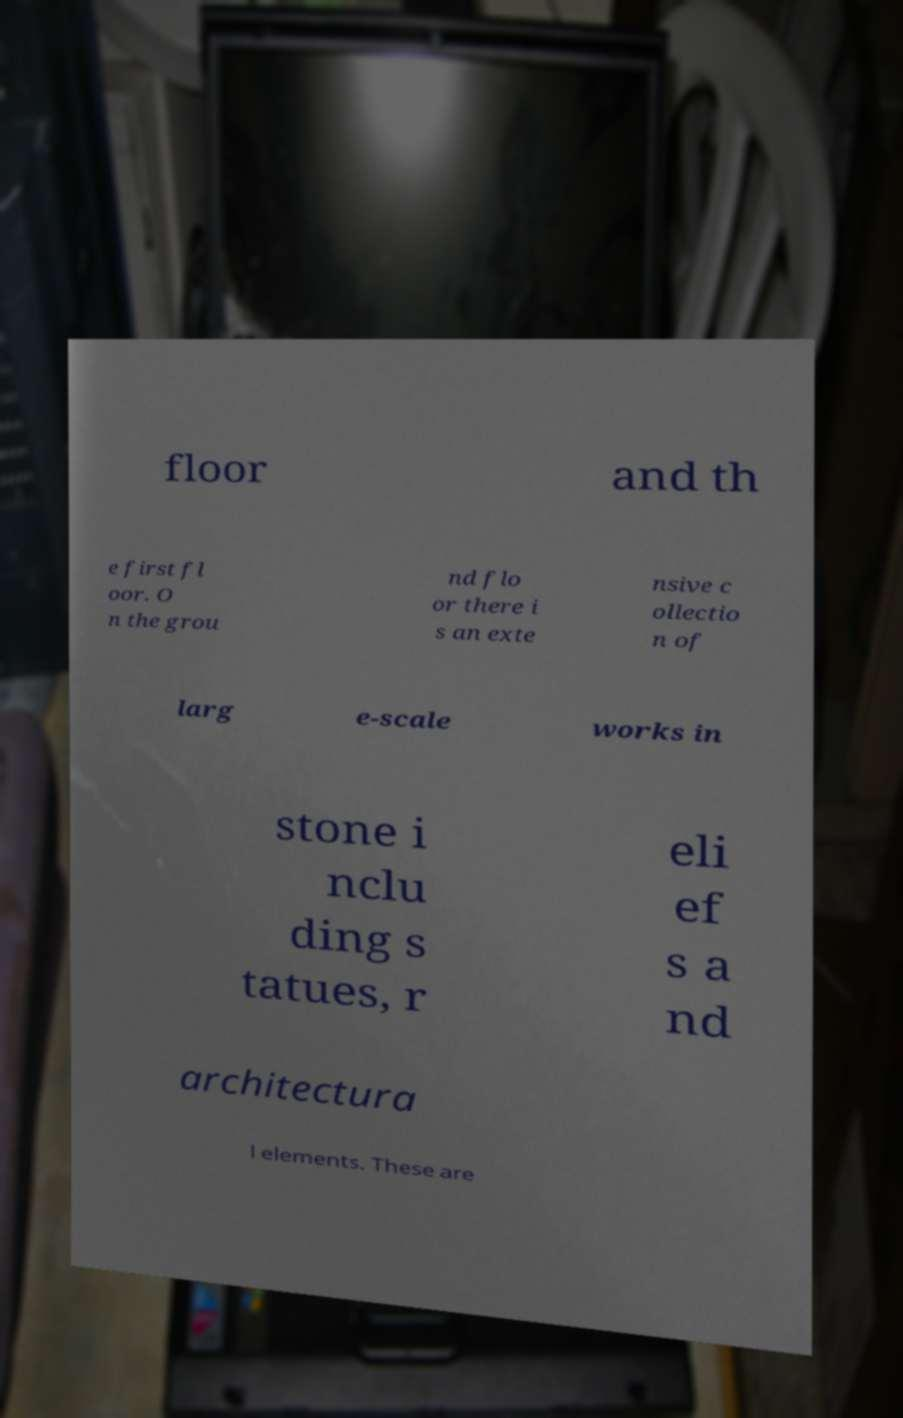Can you read and provide the text displayed in the image?This photo seems to have some interesting text. Can you extract and type it out for me? floor and th e first fl oor. O n the grou nd flo or there i s an exte nsive c ollectio n of larg e-scale works in stone i nclu ding s tatues, r eli ef s a nd architectura l elements. These are 